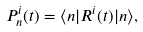<formula> <loc_0><loc_0><loc_500><loc_500>P ^ { i } _ { n } ( t ) = \langle n | R ^ { i } ( t ) | n \rangle ,</formula> 